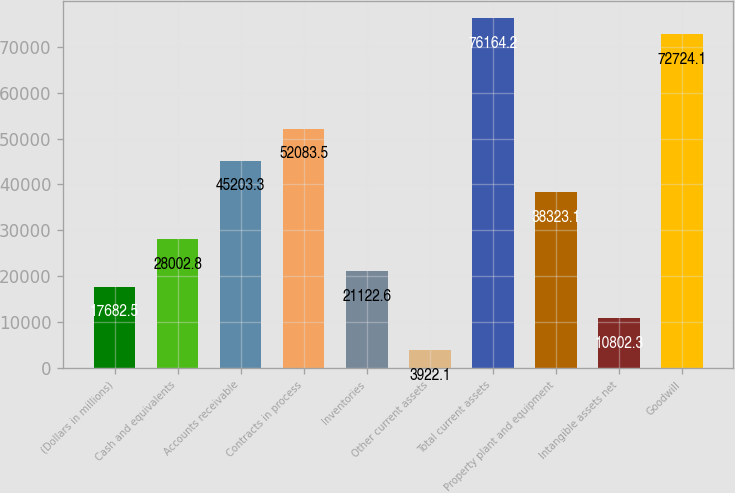Convert chart to OTSL. <chart><loc_0><loc_0><loc_500><loc_500><bar_chart><fcel>(Dollars in millions)<fcel>Cash and equivalents<fcel>Accounts receivable<fcel>Contracts in process<fcel>Inventories<fcel>Other current assets<fcel>Total current assets<fcel>Property plant and equipment<fcel>Intangible assets net<fcel>Goodwill<nl><fcel>17682.5<fcel>28002.8<fcel>45203.3<fcel>52083.5<fcel>21122.6<fcel>3922.1<fcel>76164.2<fcel>38323.1<fcel>10802.3<fcel>72724.1<nl></chart> 